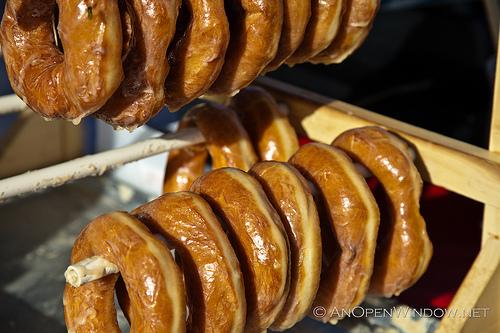What is the purpose of the white stick in the image? The white stick serves to hold the donuts, possibly to allow them to dry or to display them for sale. Describe the surface under the donuts. The surface under the donuts is a gray area, which appears blurry. Explain the current state of the donuts in the image. The donuts are glazed, shiny, and hanging on a white stick, with signs of glaze dripping and appearing sticky. How many donuts are on the middle stick? There are two donuts on the middle stick. Count the number of brown donuts explicitly mentioned in the image information. There are four brown donuts mentioned. What complex reasoning task could be done on this image? Analyzing the relation between the wooden frame, the white stick holding the donuts, and the interaction of light with the glazed surface of the donuts. Identify the primary elements in the image and describe their appearance. The primary elements are donuts, which are golden brown and shiny; a white glazed stick holding the donuts; and wooden beams supporting the structure. Determine the sentiment evoked by this image. This image creates a feeling of indulgence, with the shiny, glazed donuts appearing tempting and visually appealing. What color are the letters in the image, and what are the donuts reflecting? The letters are white, and the donuts are reflecting light. Create a sentence that describes the donuts and their environment in an elaborate manner. A row of glistening glazed golden brown donuts hang elegantly on a pristine white bar set against a rustic wooden background with a touch of glaze dripping from the donuts. Which object can be referred to as "a row of drying glazed donuts"? The donuts on the white stick Find an object in the image that can be described as "wooden beams behind the donuts." the wooden frame What is the purpose of the white stick in the image considering its relationship with donuts? The white stick is used to hold the donuts and allow them to dry. What is one characteristic of the donuts' glaze? It is sticky. Can you find a stick covered in red glaze? The only stick mentioned in the image is a white glaze-covered stick, not red. Give a unique description for the donuts' appearance. The donuts are radiant and smooth, like glazed porcelain art pieces. Point out an object in the image that is related to the phrase "donut with a hole". the hole of a donut Is there a green table in the image? There is no mention of a green table in the image, only the edge and part of a table are described. Design a poster depicting the image with a catchphrase that combines the donuts and their setting. "Golden treasures hang in harmony - taste the sweet symphony of glazed donuts!" What action/process are the donuts undergoing? Drying Read the letters present in the image and provide their color. The letters are white. Can you find a blue donut in the image? There are no blue donuts in the image, all of the described donuts are golden brown. Determine the expression of the donuts in the image. Not applicable as donuts do not have expressions What are the colors of the donuts and the stick they are hanging on? Donuts are golden brown, and the stick is white. Identify the objects that are part of the table in the image. part of a table, edge of a table Find the object described as "a gray surface under the donuts." the ground Explain the organization of the objects in the image. Donuts are hanging on a white stick attached to a wooden frame and are arranged in a row on different rods. Can you locate a cake with a pink frosting in the image? The image only mentions the edge and part of a cake, but no information about the frosting color is provided. Identify an event occurring in the image. drying of glazed donuts Is there a clear view of the wooden beams in the foreground of the image? The wooden beams are described as being behind the donuts, not in the foreground. Identify the primary setting where the donuts are displayed. A wooden frame on a box What supports the donuts in the image? A white rod Is there any donut without a hole in the image? The described donuts all have holes in them, according to image captions. What is hanging on the white stick? Donuts Describe the donuts in the image. Golden brown, glazed, shiny, and reflecting the light 